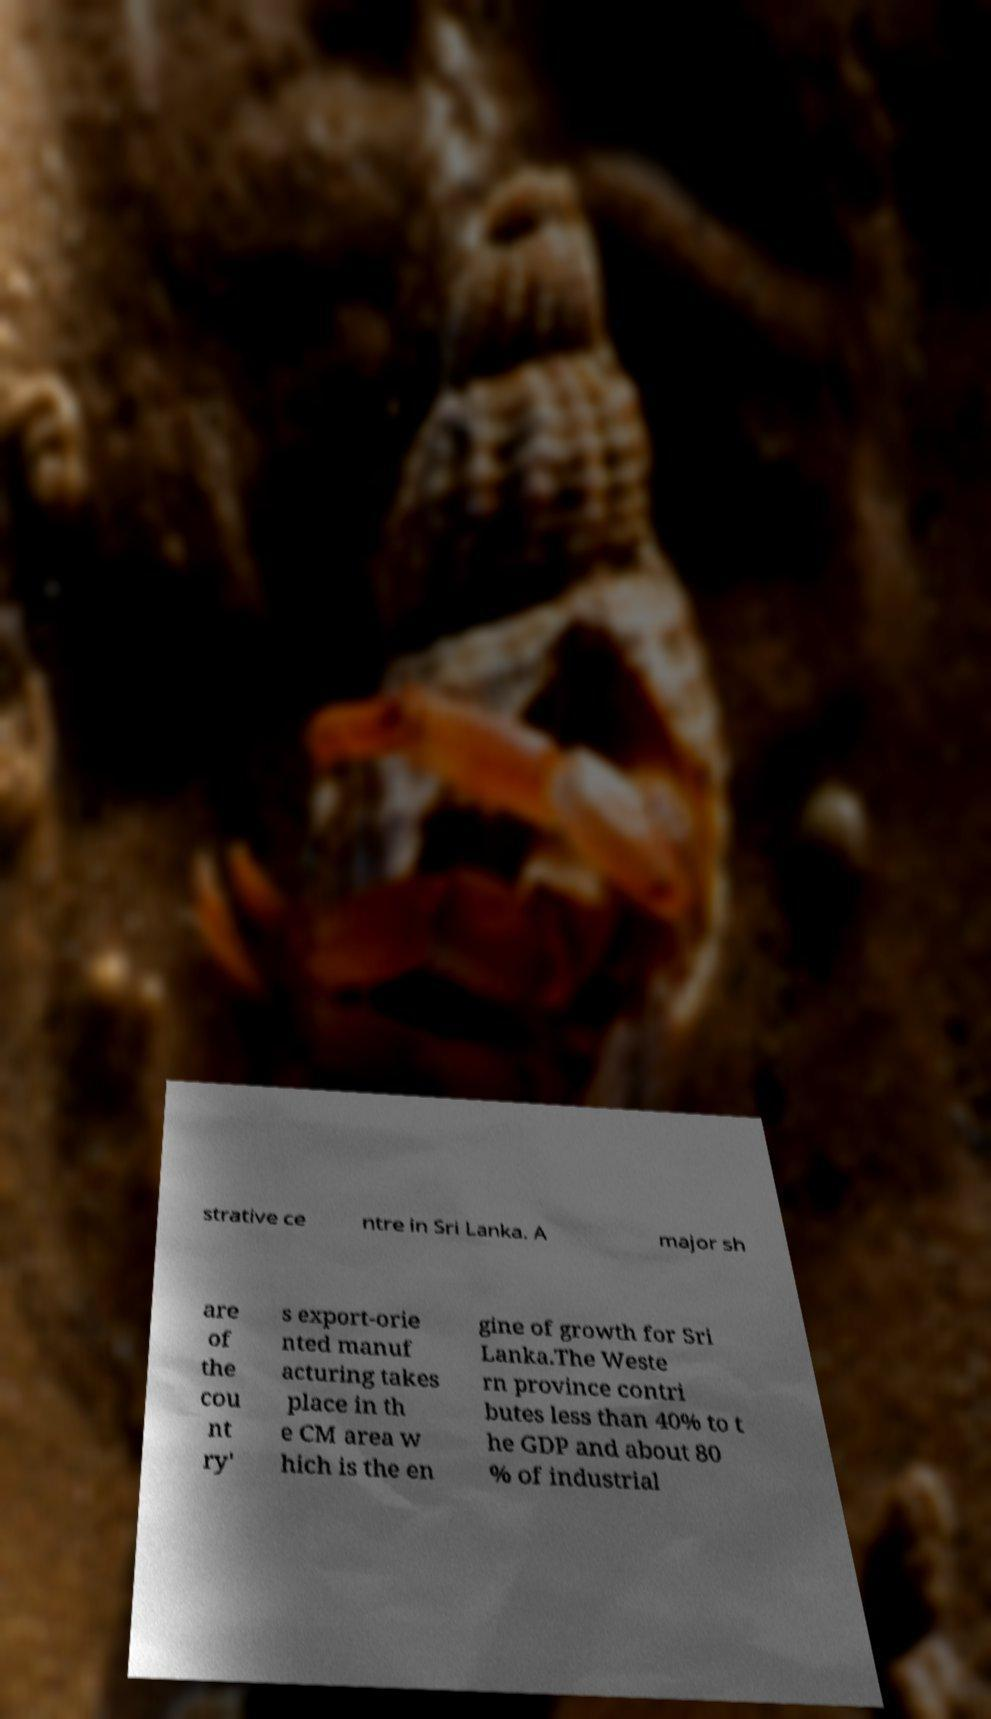There's text embedded in this image that I need extracted. Can you transcribe it verbatim? strative ce ntre in Sri Lanka. A major sh are of the cou nt ry' s export-orie nted manuf acturing takes place in th e CM area w hich is the en gine of growth for Sri Lanka.The Weste rn province contri butes less than 40% to t he GDP and about 80 % of industrial 